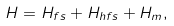Convert formula to latex. <formula><loc_0><loc_0><loc_500><loc_500>H = H _ { f s } + H _ { h f s } + H _ { m } ,</formula> 